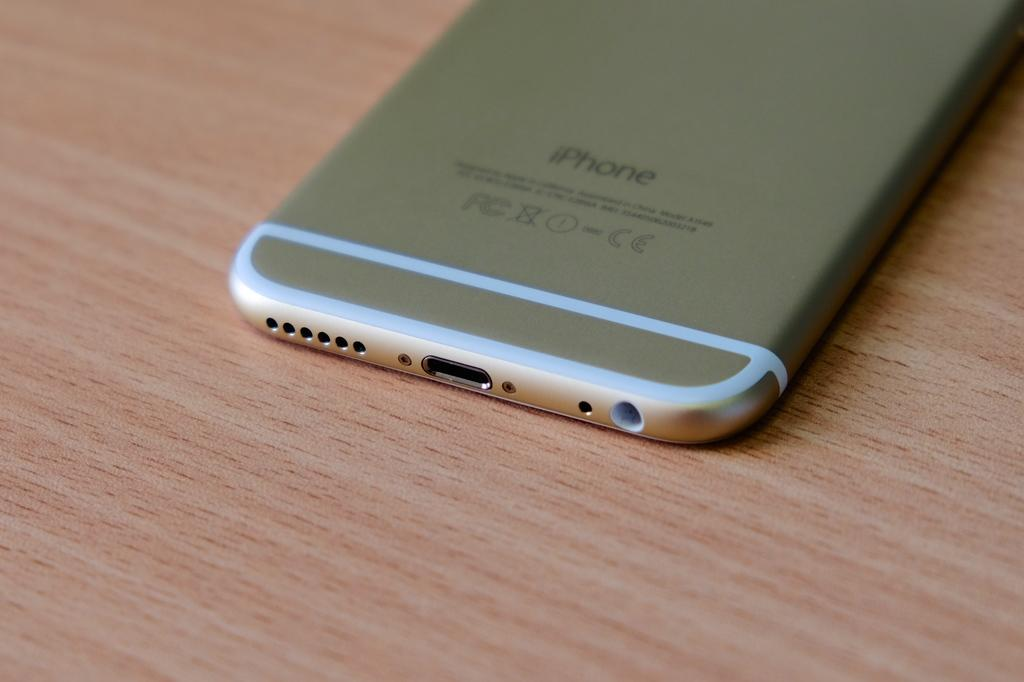<image>
Write a terse but informative summary of the picture. An iphone lays upside down on top of table. 